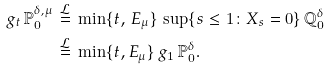Convert formula to latex. <formula><loc_0><loc_0><loc_500><loc_500>g _ { t } \, \mathbb { P } ^ { \delta , \mu } _ { 0 } \, & \stackrel { \mathcal { L } } { = } \, \min \{ t , \, E _ { \mu } \} \, \sup \{ s \leq 1 \colon X _ { s } = 0 \} \, \mathbb { Q } _ { 0 } ^ { \delta } \\ & \stackrel { \mathcal { L } } { = } \, \min \{ t , E _ { \mu } \} \, g _ { 1 } \, \mathbb { P } _ { 0 } ^ { \delta } .</formula> 